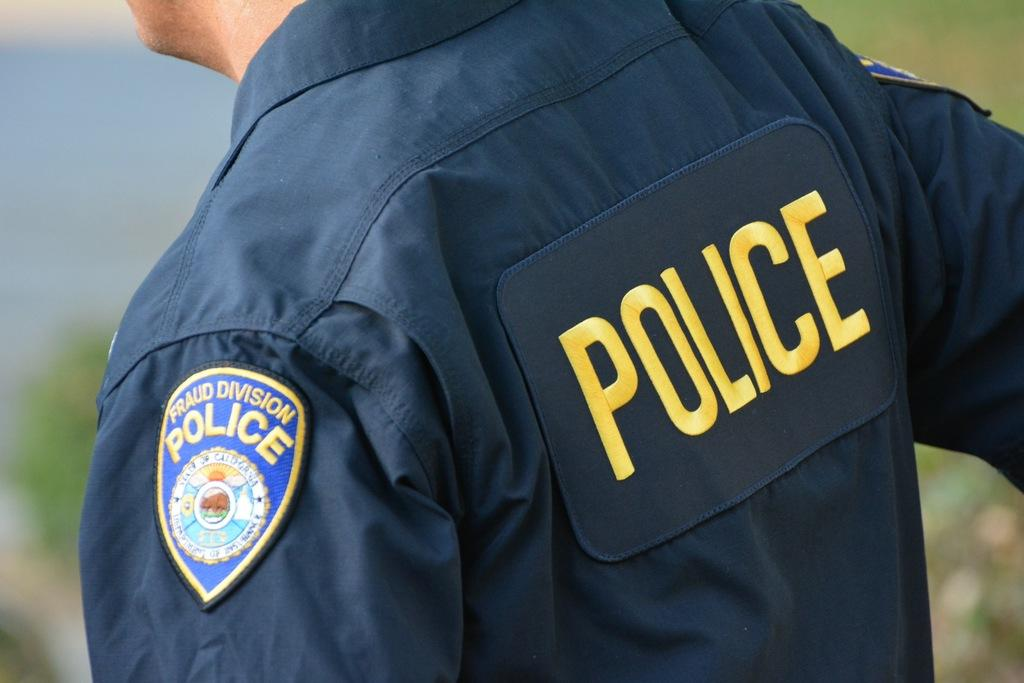<image>
Relay a brief, clear account of the picture shown. Back of a policeman wearing a badge on his left arm. 